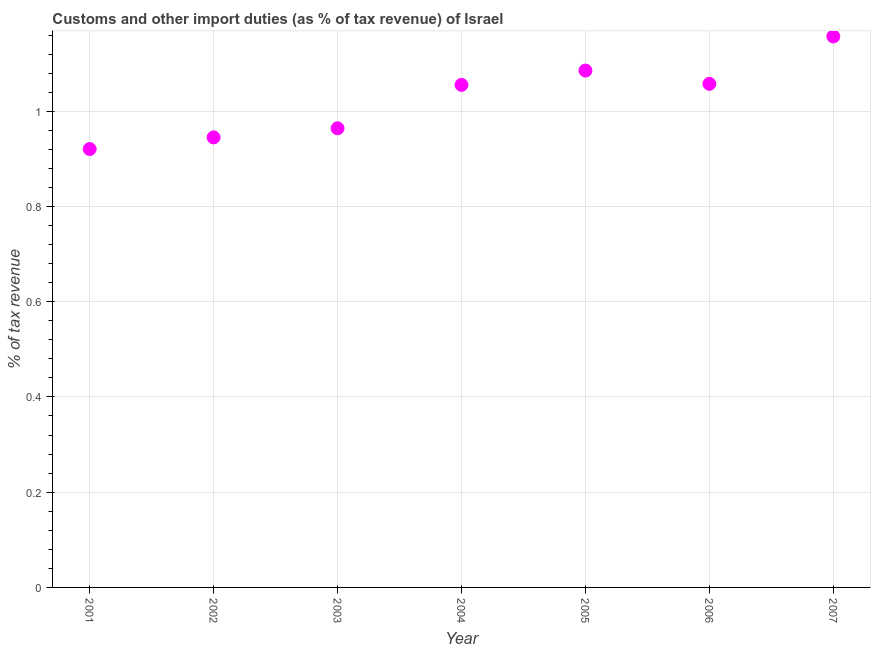What is the customs and other import duties in 2007?
Offer a very short reply. 1.16. Across all years, what is the maximum customs and other import duties?
Make the answer very short. 1.16. Across all years, what is the minimum customs and other import duties?
Your response must be concise. 0.92. In which year was the customs and other import duties maximum?
Your answer should be very brief. 2007. What is the sum of the customs and other import duties?
Offer a terse response. 7.19. What is the difference between the customs and other import duties in 2002 and 2007?
Your answer should be very brief. -0.21. What is the average customs and other import duties per year?
Provide a short and direct response. 1.03. What is the median customs and other import duties?
Ensure brevity in your answer.  1.06. What is the ratio of the customs and other import duties in 2004 to that in 2005?
Ensure brevity in your answer.  0.97. What is the difference between the highest and the second highest customs and other import duties?
Keep it short and to the point. 0.07. Is the sum of the customs and other import duties in 2001 and 2003 greater than the maximum customs and other import duties across all years?
Offer a terse response. Yes. What is the difference between the highest and the lowest customs and other import duties?
Offer a very short reply. 0.24. In how many years, is the customs and other import duties greater than the average customs and other import duties taken over all years?
Your response must be concise. 4. Does the customs and other import duties monotonically increase over the years?
Your answer should be very brief. No. How many dotlines are there?
Provide a short and direct response. 1. What is the difference between two consecutive major ticks on the Y-axis?
Offer a very short reply. 0.2. Are the values on the major ticks of Y-axis written in scientific E-notation?
Give a very brief answer. No. Does the graph contain grids?
Keep it short and to the point. Yes. What is the title of the graph?
Keep it short and to the point. Customs and other import duties (as % of tax revenue) of Israel. What is the label or title of the Y-axis?
Make the answer very short. % of tax revenue. What is the % of tax revenue in 2001?
Provide a short and direct response. 0.92. What is the % of tax revenue in 2002?
Offer a very short reply. 0.95. What is the % of tax revenue in 2003?
Make the answer very short. 0.96. What is the % of tax revenue in 2004?
Ensure brevity in your answer.  1.06. What is the % of tax revenue in 2005?
Provide a short and direct response. 1.09. What is the % of tax revenue in 2006?
Provide a succinct answer. 1.06. What is the % of tax revenue in 2007?
Your answer should be compact. 1.16. What is the difference between the % of tax revenue in 2001 and 2002?
Keep it short and to the point. -0.02. What is the difference between the % of tax revenue in 2001 and 2003?
Your answer should be very brief. -0.04. What is the difference between the % of tax revenue in 2001 and 2004?
Give a very brief answer. -0.13. What is the difference between the % of tax revenue in 2001 and 2005?
Keep it short and to the point. -0.16. What is the difference between the % of tax revenue in 2001 and 2006?
Your answer should be very brief. -0.14. What is the difference between the % of tax revenue in 2001 and 2007?
Your answer should be very brief. -0.24. What is the difference between the % of tax revenue in 2002 and 2003?
Make the answer very short. -0.02. What is the difference between the % of tax revenue in 2002 and 2004?
Make the answer very short. -0.11. What is the difference between the % of tax revenue in 2002 and 2005?
Offer a terse response. -0.14. What is the difference between the % of tax revenue in 2002 and 2006?
Give a very brief answer. -0.11. What is the difference between the % of tax revenue in 2002 and 2007?
Offer a very short reply. -0.21. What is the difference between the % of tax revenue in 2003 and 2004?
Give a very brief answer. -0.09. What is the difference between the % of tax revenue in 2003 and 2005?
Your response must be concise. -0.12. What is the difference between the % of tax revenue in 2003 and 2006?
Provide a short and direct response. -0.09. What is the difference between the % of tax revenue in 2003 and 2007?
Provide a succinct answer. -0.19. What is the difference between the % of tax revenue in 2004 and 2005?
Make the answer very short. -0.03. What is the difference between the % of tax revenue in 2004 and 2006?
Ensure brevity in your answer.  -0. What is the difference between the % of tax revenue in 2004 and 2007?
Provide a succinct answer. -0.1. What is the difference between the % of tax revenue in 2005 and 2006?
Provide a succinct answer. 0.03. What is the difference between the % of tax revenue in 2005 and 2007?
Offer a very short reply. -0.07. What is the difference between the % of tax revenue in 2006 and 2007?
Your answer should be compact. -0.1. What is the ratio of the % of tax revenue in 2001 to that in 2002?
Provide a short and direct response. 0.97. What is the ratio of the % of tax revenue in 2001 to that in 2003?
Offer a very short reply. 0.95. What is the ratio of the % of tax revenue in 2001 to that in 2004?
Your answer should be compact. 0.87. What is the ratio of the % of tax revenue in 2001 to that in 2005?
Ensure brevity in your answer.  0.85. What is the ratio of the % of tax revenue in 2001 to that in 2006?
Your answer should be compact. 0.87. What is the ratio of the % of tax revenue in 2001 to that in 2007?
Offer a very short reply. 0.8. What is the ratio of the % of tax revenue in 2002 to that in 2003?
Offer a terse response. 0.98. What is the ratio of the % of tax revenue in 2002 to that in 2004?
Ensure brevity in your answer.  0.9. What is the ratio of the % of tax revenue in 2002 to that in 2005?
Offer a very short reply. 0.87. What is the ratio of the % of tax revenue in 2002 to that in 2006?
Offer a terse response. 0.89. What is the ratio of the % of tax revenue in 2002 to that in 2007?
Give a very brief answer. 0.82. What is the ratio of the % of tax revenue in 2003 to that in 2004?
Give a very brief answer. 0.91. What is the ratio of the % of tax revenue in 2003 to that in 2005?
Make the answer very short. 0.89. What is the ratio of the % of tax revenue in 2003 to that in 2006?
Your answer should be compact. 0.91. What is the ratio of the % of tax revenue in 2003 to that in 2007?
Keep it short and to the point. 0.83. What is the ratio of the % of tax revenue in 2004 to that in 2005?
Your answer should be compact. 0.97. What is the ratio of the % of tax revenue in 2004 to that in 2006?
Keep it short and to the point. 1. What is the ratio of the % of tax revenue in 2004 to that in 2007?
Give a very brief answer. 0.91. What is the ratio of the % of tax revenue in 2005 to that in 2007?
Offer a terse response. 0.94. What is the ratio of the % of tax revenue in 2006 to that in 2007?
Offer a terse response. 0.91. 